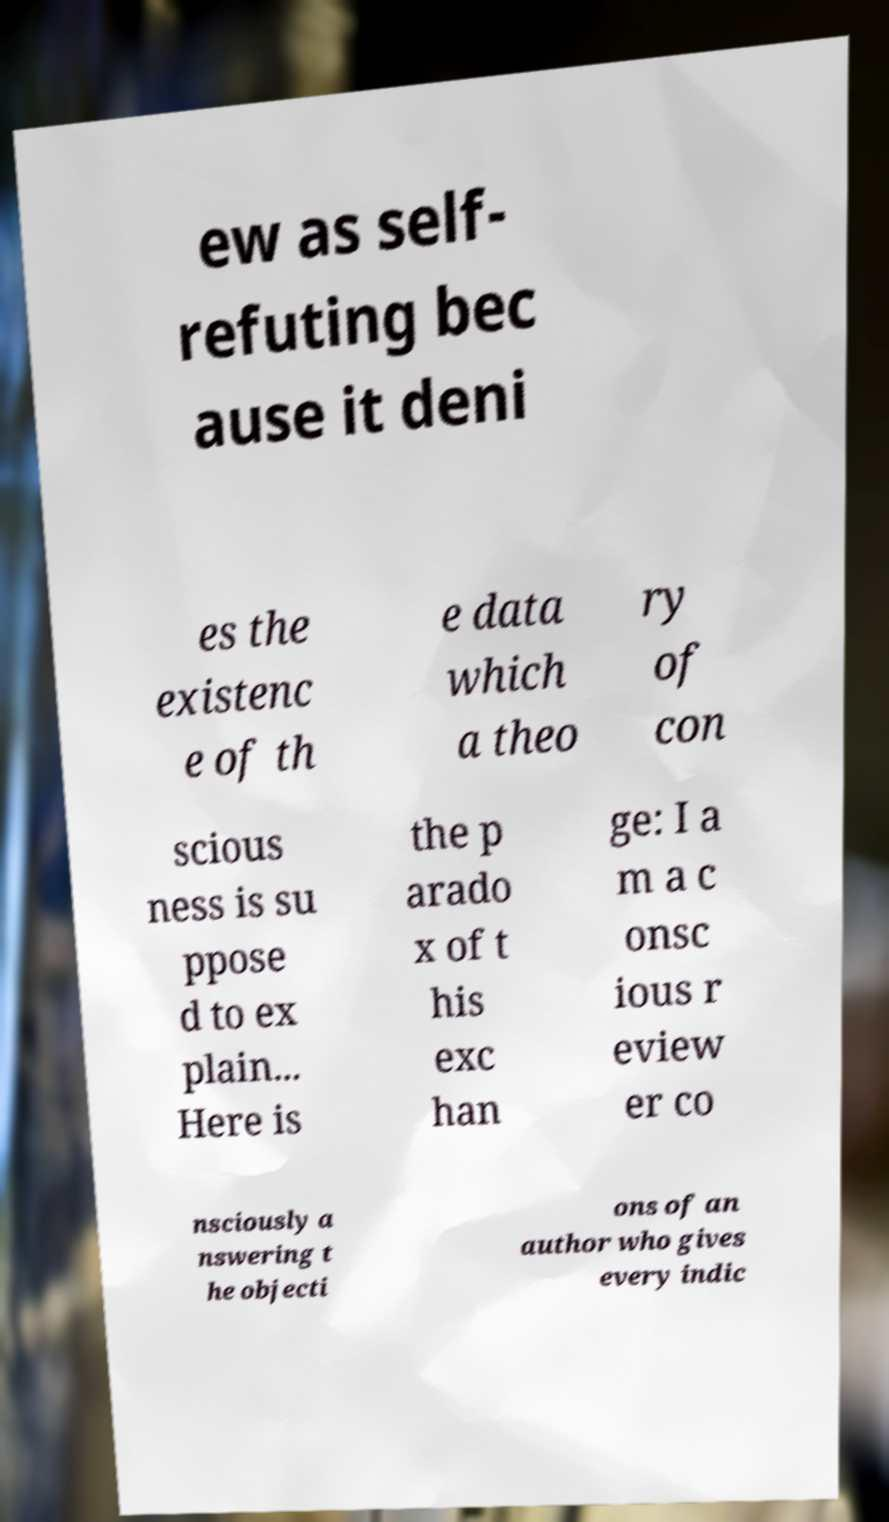Can you accurately transcribe the text from the provided image for me? ew as self- refuting bec ause it deni es the existenc e of th e data which a theo ry of con scious ness is su ppose d to ex plain... Here is the p arado x of t his exc han ge: I a m a c onsc ious r eview er co nsciously a nswering t he objecti ons of an author who gives every indic 